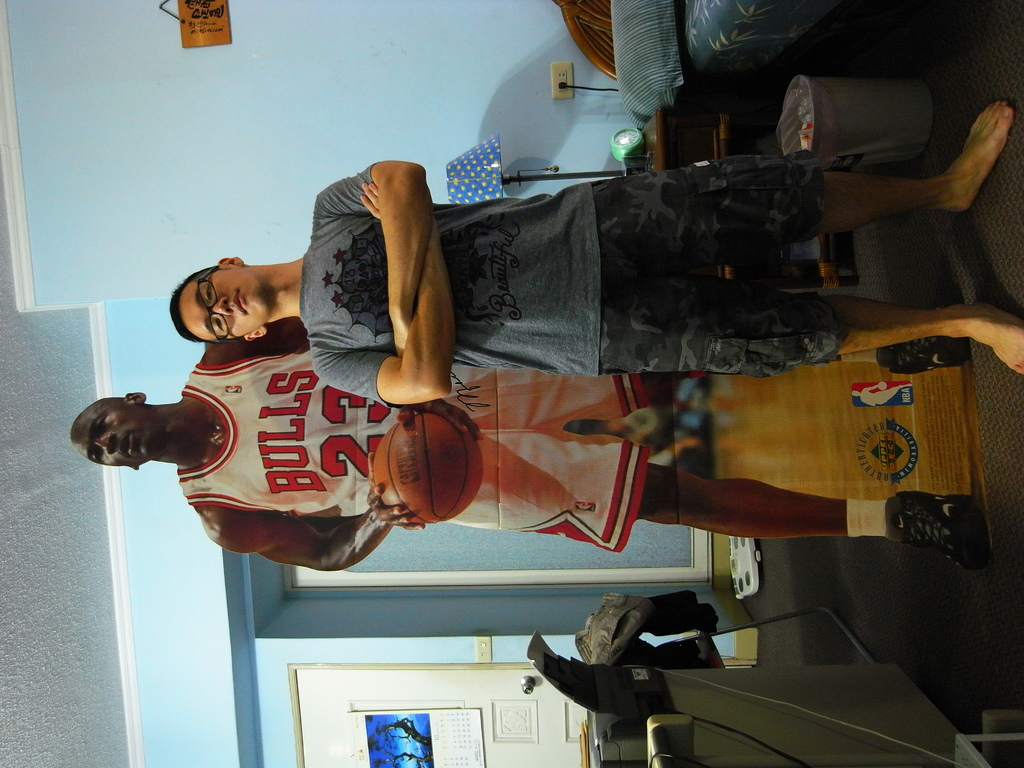How does the lighting affect the atmosphere of the image? The soft, ambient lighting in the room creates a relaxed and homely environment, which enhances the casual pose of the man and gives a comforting glow to the poster. 